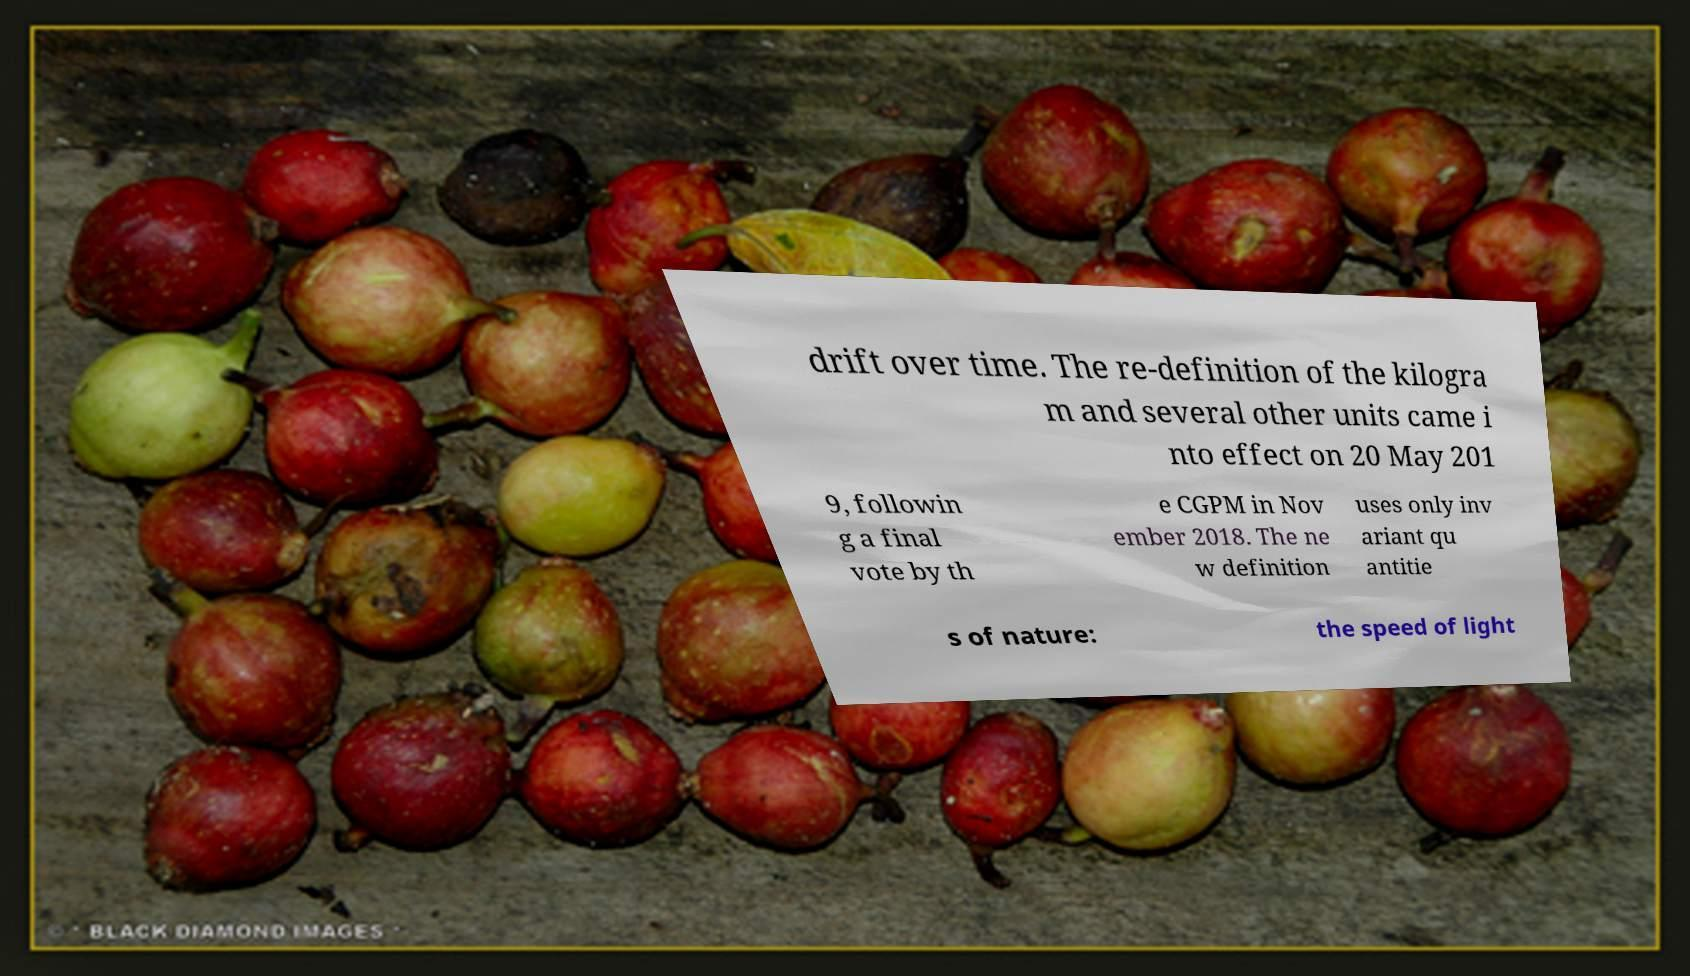Can you accurately transcribe the text from the provided image for me? drift over time. The re-definition of the kilogra m and several other units came i nto effect on 20 May 201 9, followin g a final vote by th e CGPM in Nov ember 2018. The ne w definition uses only inv ariant qu antitie s of nature: the speed of light 